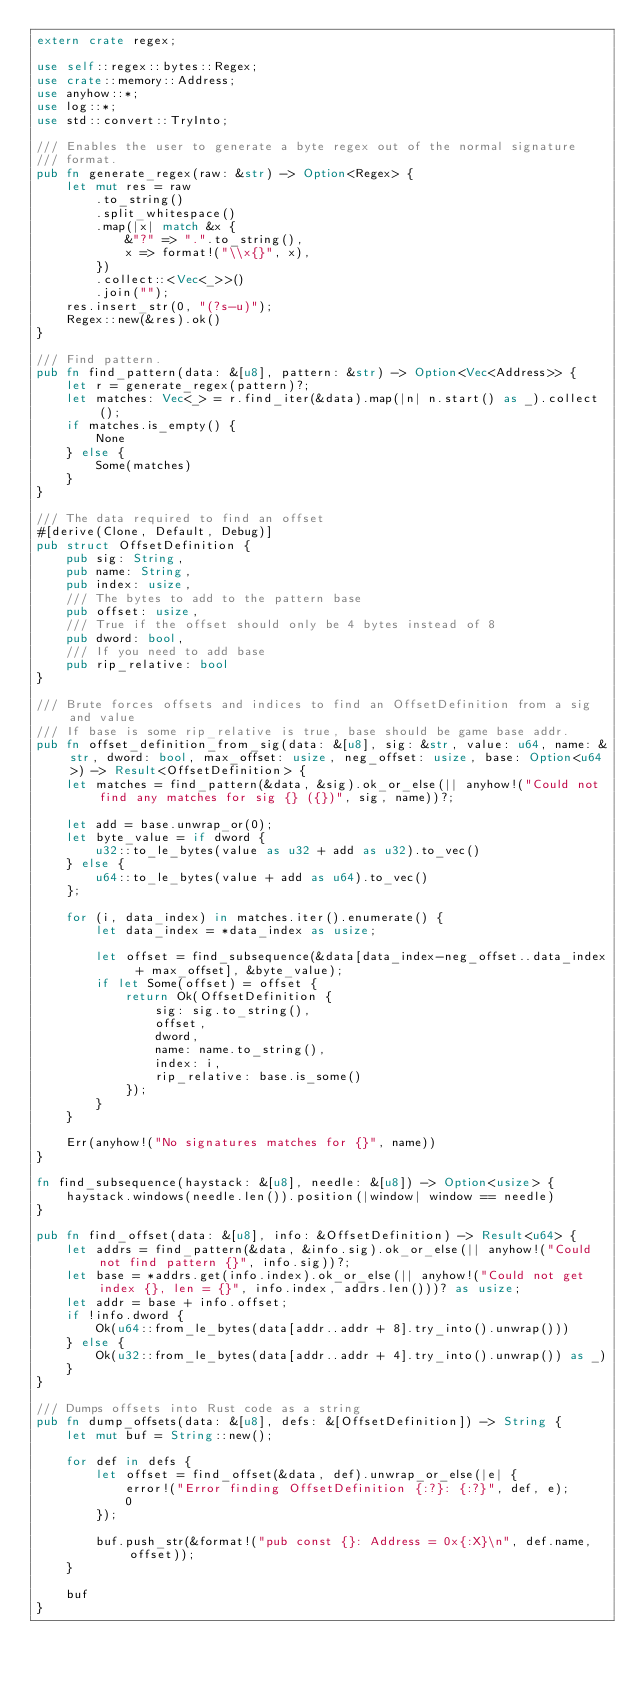<code> <loc_0><loc_0><loc_500><loc_500><_Rust_>extern crate regex;

use self::regex::bytes::Regex;
use crate::memory::Address;
use anyhow::*;
use log::*;
use std::convert::TryInto;

/// Enables the user to generate a byte regex out of the normal signature
/// format.
pub fn generate_regex(raw: &str) -> Option<Regex> {
    let mut res = raw
        .to_string()
        .split_whitespace()
        .map(|x| match &x {
            &"?" => ".".to_string(),
            x => format!("\\x{}", x),
        })
        .collect::<Vec<_>>()
        .join("");
    res.insert_str(0, "(?s-u)");
    Regex::new(&res).ok()
}

/// Find pattern.
pub fn find_pattern(data: &[u8], pattern: &str) -> Option<Vec<Address>> {
    let r = generate_regex(pattern)?;
    let matches: Vec<_> = r.find_iter(&data).map(|n| n.start() as _).collect();
    if matches.is_empty() {
        None
    } else {
        Some(matches)
    }
}

/// The data required to find an offset
#[derive(Clone, Default, Debug)]
pub struct OffsetDefinition {
    pub sig: String,
    pub name: String,
    pub index: usize,
    /// The bytes to add to the pattern base
    pub offset: usize,
    /// True if the offset should only be 4 bytes instead of 8
    pub dword: bool,
    /// If you need to add base
    pub rip_relative: bool
}

/// Brute forces offsets and indices to find an OffsetDefinition from a sig and value
/// If base is some rip_relative is true, base should be game base addr.
pub fn offset_definition_from_sig(data: &[u8], sig: &str, value: u64, name: &str, dword: bool, max_offset: usize, neg_offset: usize, base: Option<u64>) -> Result<OffsetDefinition> {
    let matches = find_pattern(&data, &sig).ok_or_else(|| anyhow!("Could not find any matches for sig {} ({})", sig, name))?;

    let add = base.unwrap_or(0);
    let byte_value = if dword {
        u32::to_le_bytes(value as u32 + add as u32).to_vec()
    } else {
        u64::to_le_bytes(value + add as u64).to_vec()
    };

    for (i, data_index) in matches.iter().enumerate() {
        let data_index = *data_index as usize;

        let offset = find_subsequence(&data[data_index-neg_offset..data_index + max_offset], &byte_value);
        if let Some(offset) = offset {
            return Ok(OffsetDefinition {
                sig: sig.to_string(),
                offset,
                dword,
                name: name.to_string(),
                index: i,
                rip_relative: base.is_some()
            });
        }
    }

    Err(anyhow!("No signatures matches for {}", name))
}

fn find_subsequence(haystack: &[u8], needle: &[u8]) -> Option<usize> {
    haystack.windows(needle.len()).position(|window| window == needle)
}

pub fn find_offset(data: &[u8], info: &OffsetDefinition) -> Result<u64> {
    let addrs = find_pattern(&data, &info.sig).ok_or_else(|| anyhow!("Could not find pattern {}", info.sig))?;
    let base = *addrs.get(info.index).ok_or_else(|| anyhow!("Could not get index {}, len = {}", info.index, addrs.len()))? as usize;
    let addr = base + info.offset;
    if !info.dword {
        Ok(u64::from_le_bytes(data[addr..addr + 8].try_into().unwrap()))
    } else {
        Ok(u32::from_le_bytes(data[addr..addr + 4].try_into().unwrap()) as _)
    }
}

/// Dumps offsets into Rust code as a string
pub fn dump_offsets(data: &[u8], defs: &[OffsetDefinition]) -> String {
    let mut buf = String::new();

    for def in defs {
        let offset = find_offset(&data, def).unwrap_or_else(|e| {
            error!("Error finding OffsetDefinition {:?}: {:?}", def, e);
            0
        });

        buf.push_str(&format!("pub const {}: Address = 0x{:X}\n", def.name, offset));
    }

    buf
}
</code> 